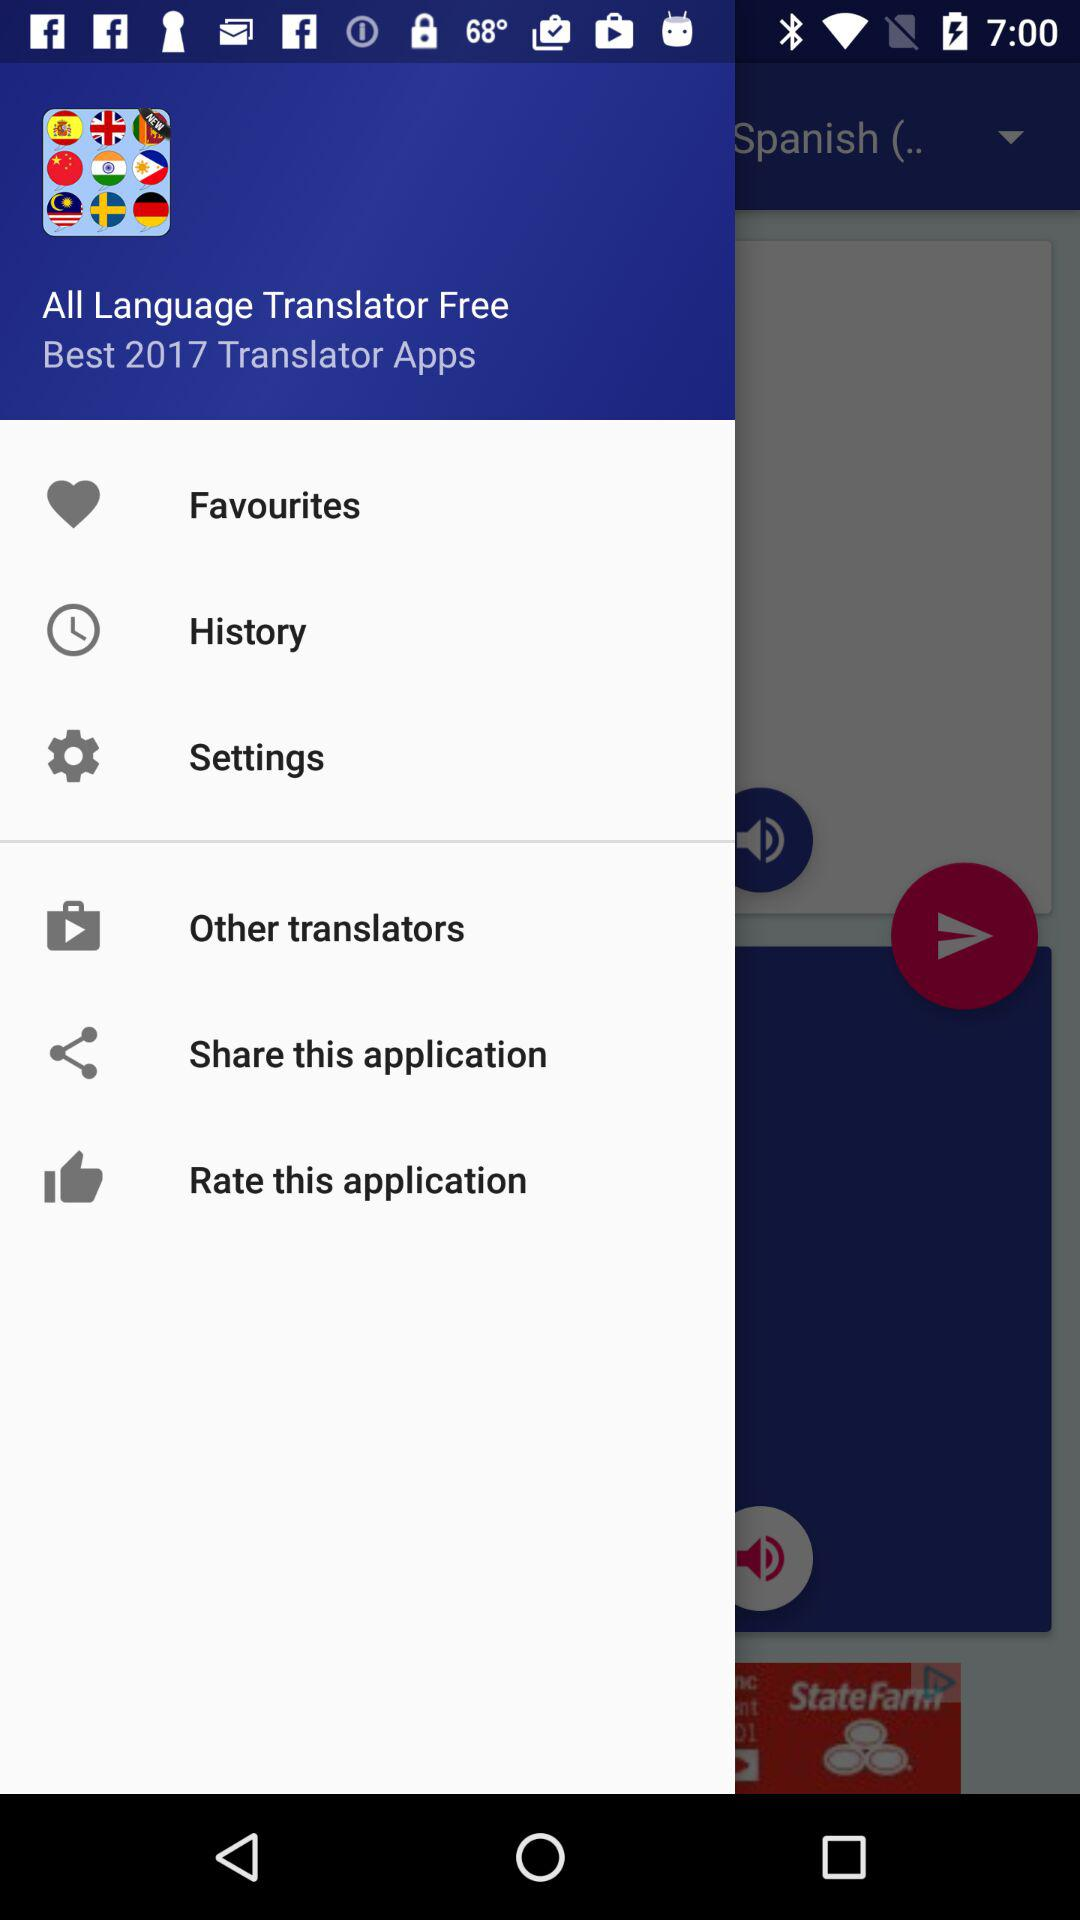Which year's best translator application is this? The year is 2017. 